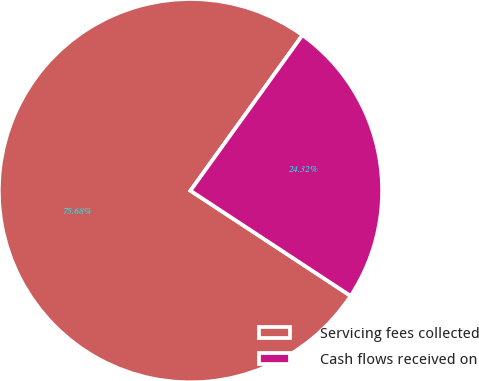Convert chart. <chart><loc_0><loc_0><loc_500><loc_500><pie_chart><fcel>Servicing fees collected<fcel>Cash flows received on<nl><fcel>75.68%<fcel>24.32%<nl></chart> 